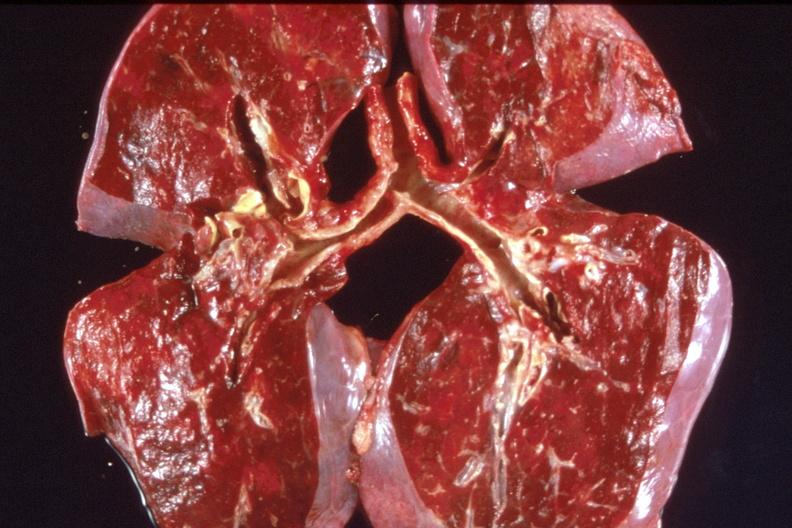s hand present?
Answer the question using a single word or phrase. No 